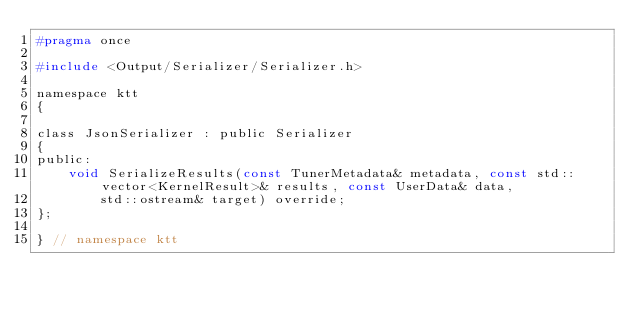Convert code to text. <code><loc_0><loc_0><loc_500><loc_500><_C_>#pragma once

#include <Output/Serializer/Serializer.h>

namespace ktt
{

class JsonSerializer : public Serializer
{
public:
    void SerializeResults(const TunerMetadata& metadata, const std::vector<KernelResult>& results, const UserData& data,
        std::ostream& target) override;
};

} // namespace ktt
</code> 